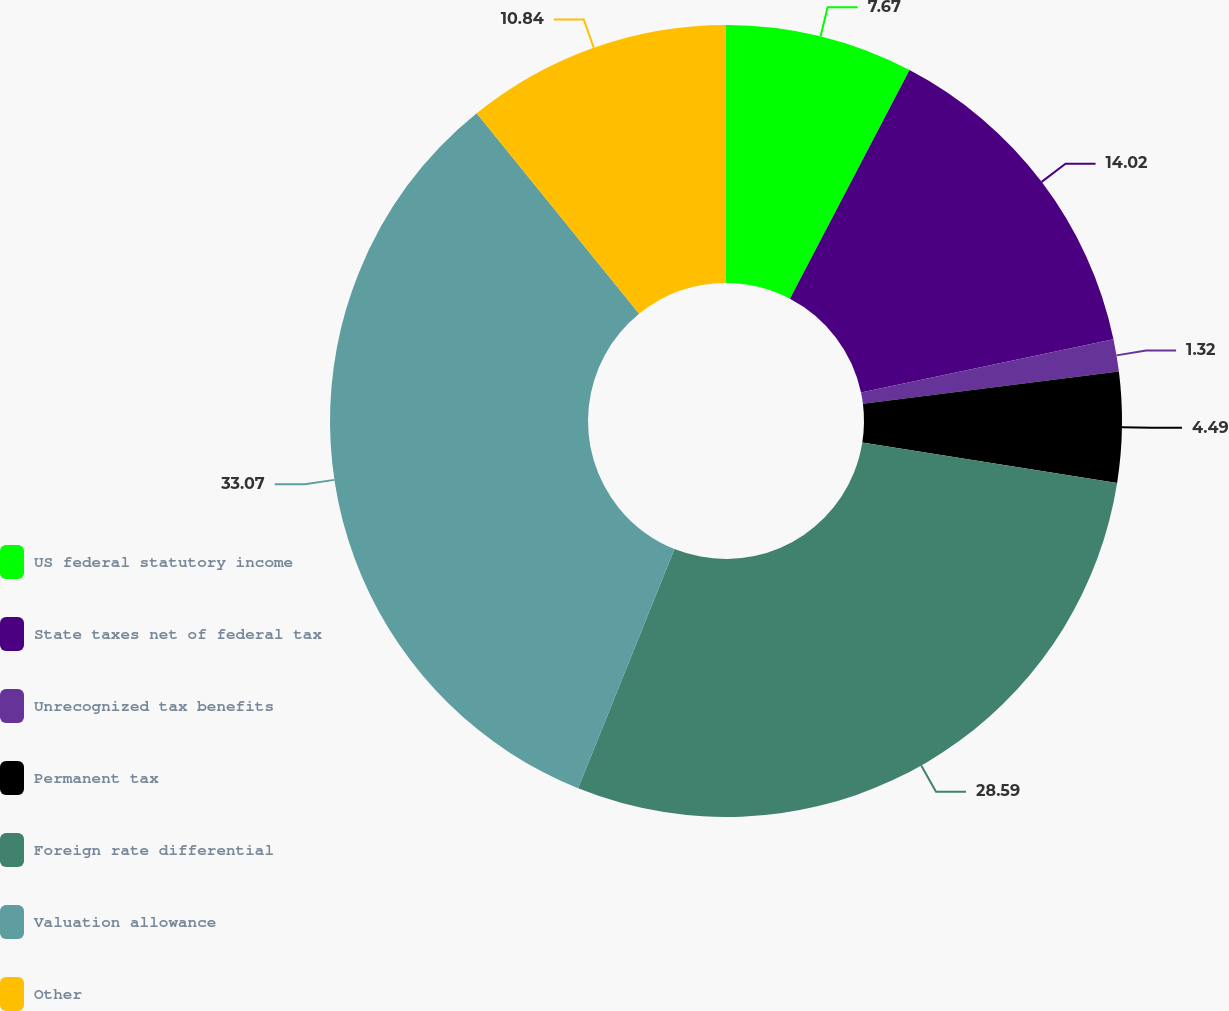Convert chart. <chart><loc_0><loc_0><loc_500><loc_500><pie_chart><fcel>US federal statutory income<fcel>State taxes net of federal tax<fcel>Unrecognized tax benefits<fcel>Permanent tax<fcel>Foreign rate differential<fcel>Valuation allowance<fcel>Other<nl><fcel>7.67%<fcel>14.02%<fcel>1.32%<fcel>4.49%<fcel>28.59%<fcel>33.07%<fcel>10.84%<nl></chart> 